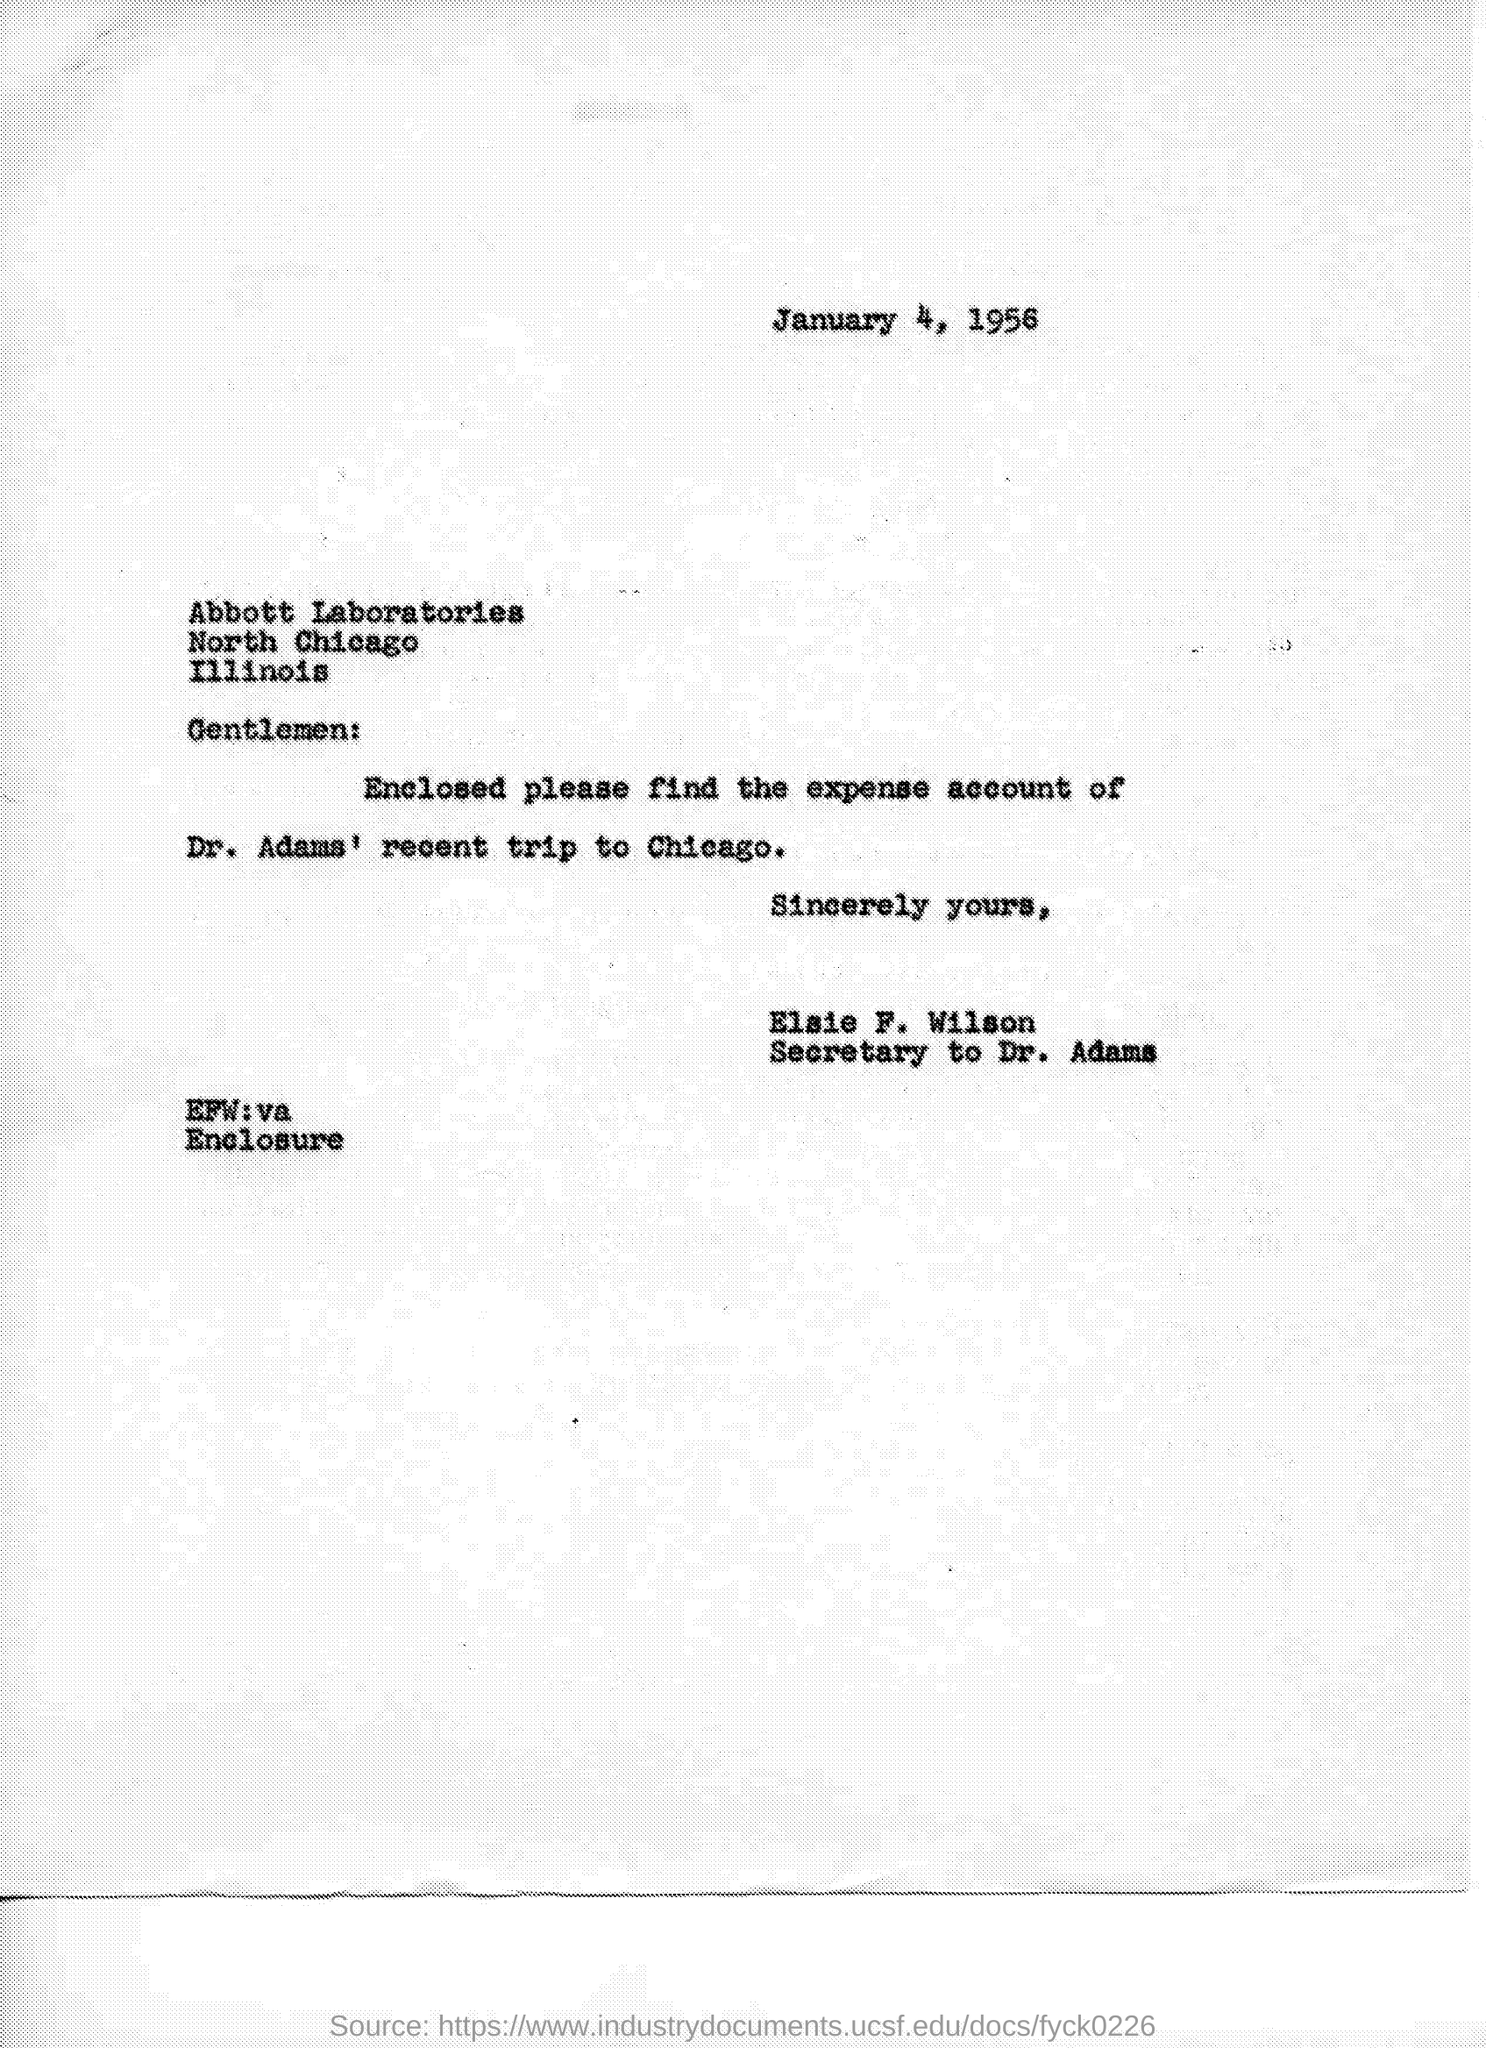Draw attention to some important aspects in this diagram. The letter is addressed to Abbott Laboratories. I hereby submit the expense account of Dr. Adams' trip to Chicago, which is enclosed. The letter is from Elsie F. Wilson. The date on the document is January 4, 1956. 